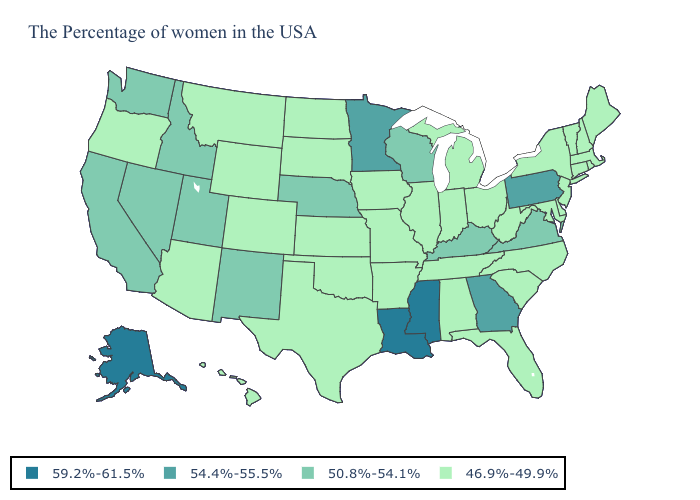What is the value of Washington?
Be succinct. 50.8%-54.1%. Name the states that have a value in the range 50.8%-54.1%?
Write a very short answer. Virginia, Kentucky, Wisconsin, Nebraska, New Mexico, Utah, Idaho, Nevada, California, Washington. What is the highest value in the USA?
Concise answer only. 59.2%-61.5%. What is the value of Maryland?
Short answer required. 46.9%-49.9%. What is the lowest value in states that border South Dakota?
Keep it brief. 46.9%-49.9%. What is the value of West Virginia?
Answer briefly. 46.9%-49.9%. What is the value of Mississippi?
Give a very brief answer. 59.2%-61.5%. Does North Dakota have the lowest value in the USA?
Quick response, please. Yes. What is the value of Texas?
Be succinct. 46.9%-49.9%. What is the value of Georgia?
Keep it brief. 54.4%-55.5%. Name the states that have a value in the range 50.8%-54.1%?
Keep it brief. Virginia, Kentucky, Wisconsin, Nebraska, New Mexico, Utah, Idaho, Nevada, California, Washington. Does the first symbol in the legend represent the smallest category?
Keep it brief. No. How many symbols are there in the legend?
Keep it brief. 4. Which states hav the highest value in the MidWest?
Answer briefly. Minnesota. What is the highest value in the Northeast ?
Write a very short answer. 54.4%-55.5%. 